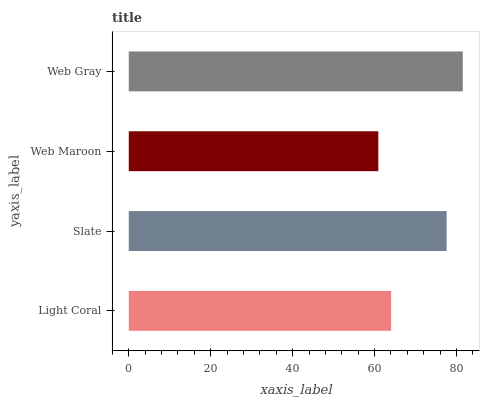Is Web Maroon the minimum?
Answer yes or no. Yes. Is Web Gray the maximum?
Answer yes or no. Yes. Is Slate the minimum?
Answer yes or no. No. Is Slate the maximum?
Answer yes or no. No. Is Slate greater than Light Coral?
Answer yes or no. Yes. Is Light Coral less than Slate?
Answer yes or no. Yes. Is Light Coral greater than Slate?
Answer yes or no. No. Is Slate less than Light Coral?
Answer yes or no. No. Is Slate the high median?
Answer yes or no. Yes. Is Light Coral the low median?
Answer yes or no. Yes. Is Web Gray the high median?
Answer yes or no. No. Is Web Gray the low median?
Answer yes or no. No. 